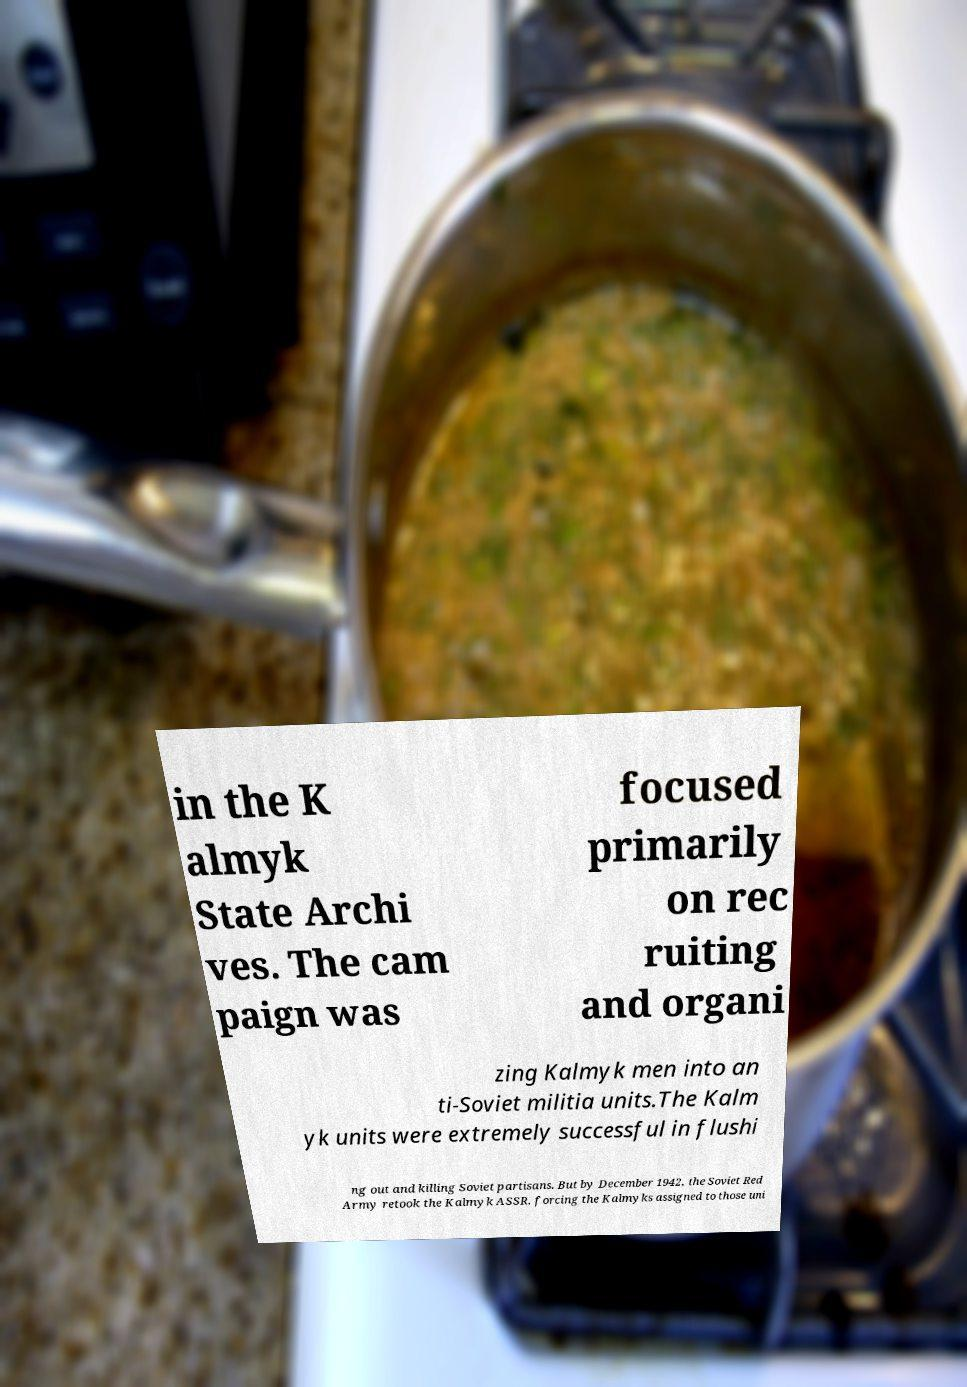Could you extract and type out the text from this image? in the K almyk State Archi ves. The cam paign was focused primarily on rec ruiting and organi zing Kalmyk men into an ti-Soviet militia units.The Kalm yk units were extremely successful in flushi ng out and killing Soviet partisans. But by December 1942, the Soviet Red Army retook the Kalmyk ASSR, forcing the Kalmyks assigned to those uni 